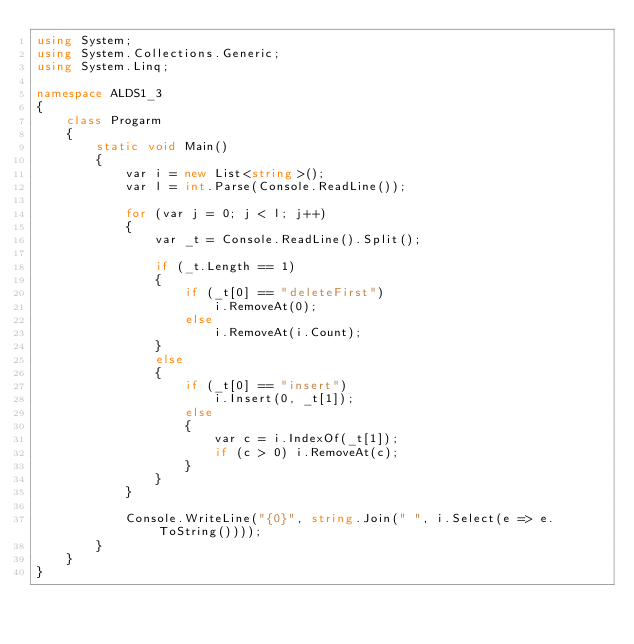Convert code to text. <code><loc_0><loc_0><loc_500><loc_500><_C#_>using System;
using System.Collections.Generic;
using System.Linq;

namespace ALDS1_3
{
    class Progarm
    {
        static void Main()
        {
            var i = new List<string>();
            var l = int.Parse(Console.ReadLine());

            for (var j = 0; j < l; j++)
            {
                var _t = Console.ReadLine().Split();
                
                if (_t.Length == 1)
                {
                    if (_t[0] == "deleteFirst")
                        i.RemoveAt(0);
                    else
                        i.RemoveAt(i.Count);
                }
                else
                {
                    if (_t[0] == "insert")
                        i.Insert(0, _t[1]);
                    else
                    {
                        var c = i.IndexOf(_t[1]);
                        if (c > 0) i.RemoveAt(c);
                    }
                }
            }

            Console.WriteLine("{0}", string.Join(" ", i.Select(e => e.ToString())));
        }
    }
}</code> 